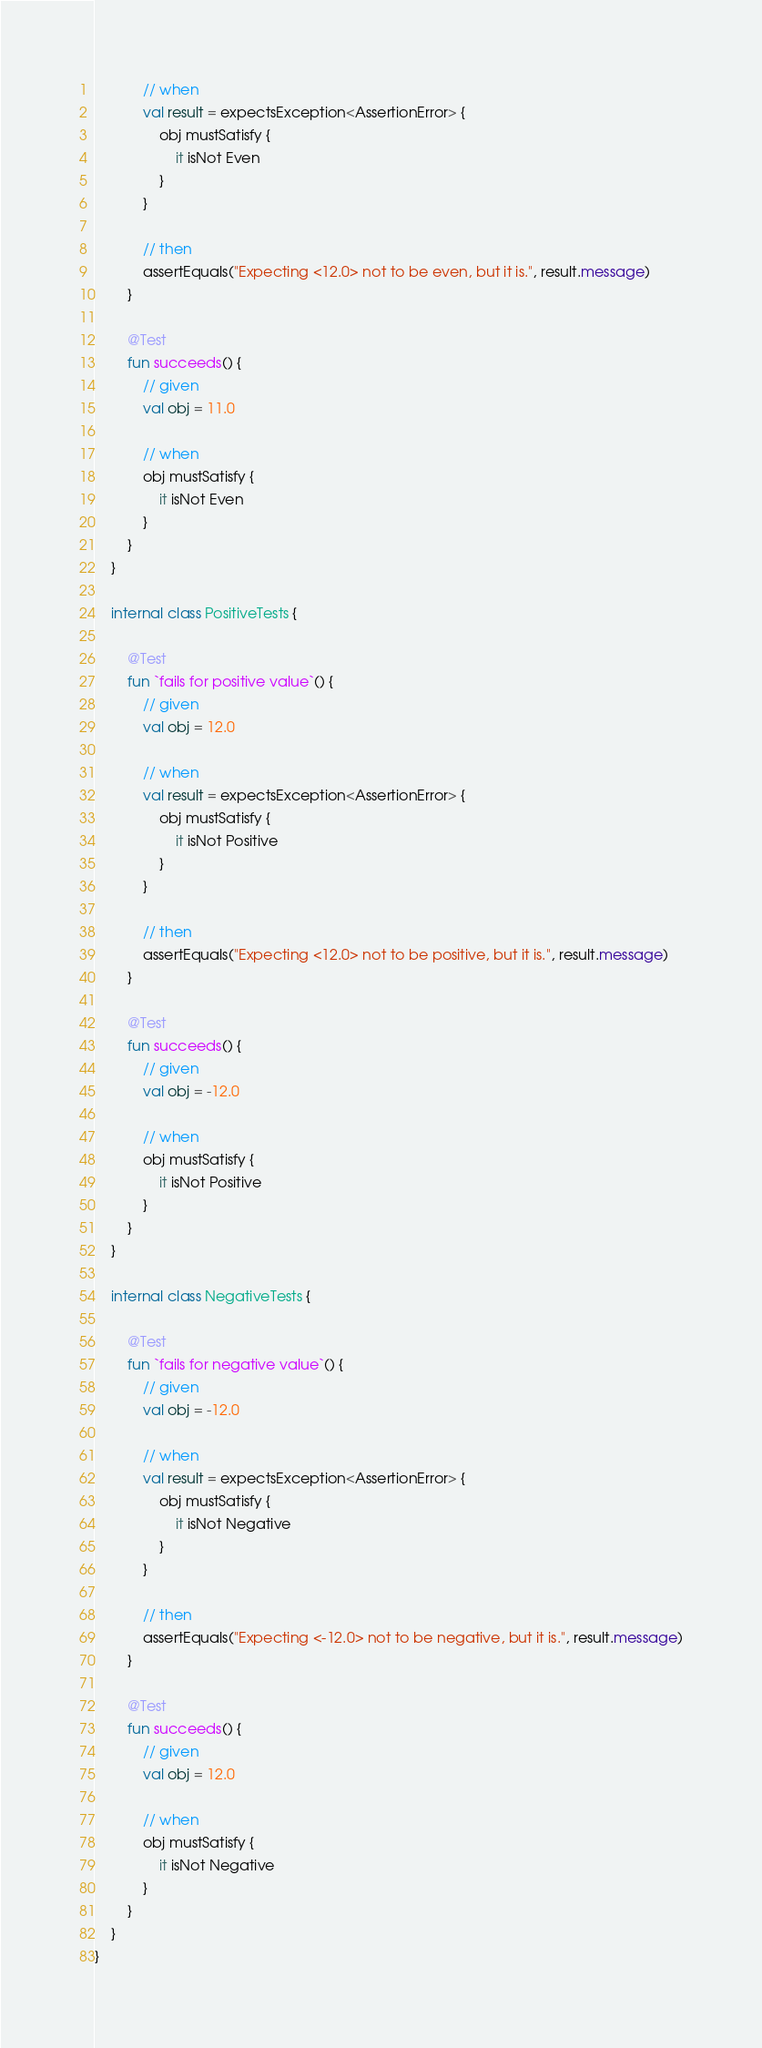Convert code to text. <code><loc_0><loc_0><loc_500><loc_500><_Kotlin_>            // when
            val result = expectsException<AssertionError> {
                obj mustSatisfy {
                    it isNot Even
                }
            }

            // then
            assertEquals("Expecting <12.0> not to be even, but it is.", result.message)
        }

        @Test
        fun succeeds() {
            // given
            val obj = 11.0

            // when
            obj mustSatisfy {
                it isNot Even
            }
        }
    }

    internal class PositiveTests {

        @Test
        fun `fails for positive value`() {
            // given
            val obj = 12.0

            // when
            val result = expectsException<AssertionError> {
                obj mustSatisfy {
                    it isNot Positive
                }
            }

            // then
            assertEquals("Expecting <12.0> not to be positive, but it is.", result.message)
        }

        @Test
        fun succeeds() {
            // given
            val obj = -12.0

            // when
            obj mustSatisfy {
                it isNot Positive
            }
        }
    }

    internal class NegativeTests {

        @Test
        fun `fails for negative value`() {
            // given
            val obj = -12.0

            // when
            val result = expectsException<AssertionError> {
                obj mustSatisfy {
                    it isNot Negative
                }
            }

            // then
            assertEquals("Expecting <-12.0> not to be negative, but it is.", result.message)
        }

        @Test
        fun succeeds() {
            // given
            val obj = 12.0

            // when
            obj mustSatisfy {
                it isNot Negative
            }
        }
    }
}</code> 